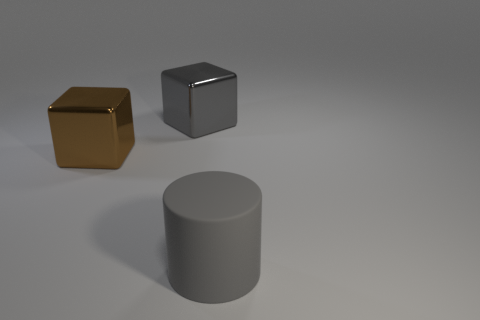Is there any other thing that has the same shape as the gray matte thing?
Provide a succinct answer. No. Does the big cube that is on the right side of the big brown metal thing have the same color as the big metal cube left of the gray shiny block?
Offer a terse response. No. What number of red things are blocks or rubber cylinders?
Ensure brevity in your answer.  0. Is the number of big gray shiny objects that are right of the matte cylinder less than the number of big gray blocks on the left side of the large gray metal thing?
Make the answer very short. No. Is there a matte object that has the same size as the brown block?
Provide a short and direct response. Yes. Does the gray thing that is on the left side of the rubber thing have the same size as the large gray matte object?
Your answer should be very brief. Yes. Are there more big gray things than matte cylinders?
Your answer should be very brief. Yes. Is there a small yellow thing that has the same shape as the big brown thing?
Your response must be concise. No. What shape is the large thing behind the brown thing?
Make the answer very short. Cube. There is a large metallic thing that is left of the gray object that is behind the big matte thing; what number of rubber cylinders are behind it?
Provide a succinct answer. 0. 